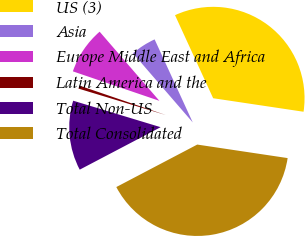Convert chart. <chart><loc_0><loc_0><loc_500><loc_500><pie_chart><fcel>US (3)<fcel>Asia<fcel>Europe Middle East and Africa<fcel>Latin America and the<fcel>Total Non-US<fcel>Total Consolidated<nl><fcel>34.21%<fcel>4.49%<fcel>8.43%<fcel>0.55%<fcel>12.37%<fcel>39.94%<nl></chart> 